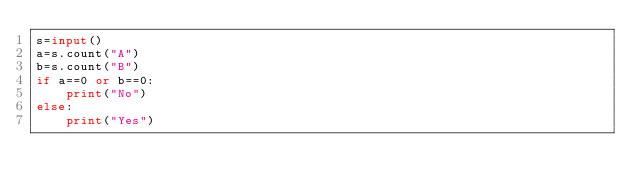Convert code to text. <code><loc_0><loc_0><loc_500><loc_500><_Python_>s=input()
a=s.count("A")
b=s.count("B")
if a==0 or b==0:
    print("No")
else:
    print("Yes")</code> 